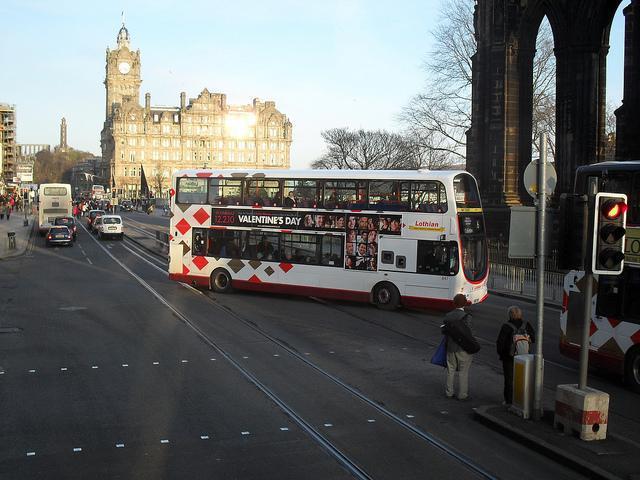How many buses are there?
Give a very brief answer. 2. 